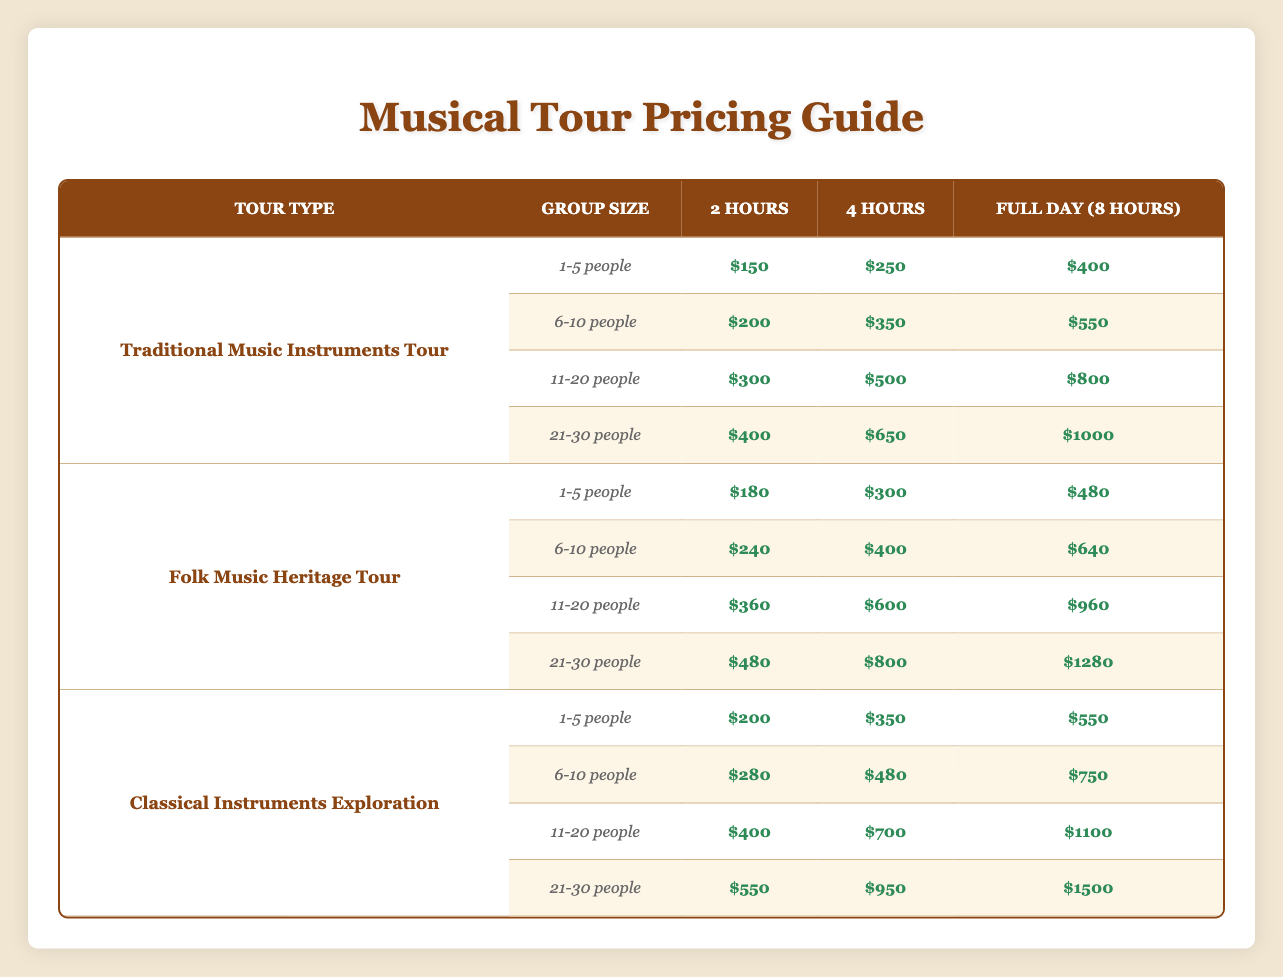What is the cost of a 4-hour Traditional Music Instruments Tour for a group of 6-10 people? Referring to the pricing table under Traditional Music Instruments Tour, for a group size of 6-10 people, the price for a 4-hour tour is $350.
Answer: $350 How much does it cost for a group of 1-5 people to take a Full day (8 hours) Folk Music Heritage Tour? Looking at the Folk Music Heritage Tour row, the price for a Full day (8 hours) tour for a group of 1-5 people is $480.
Answer: $480 Is the price for a 2-hour Classical Instruments Exploration Tour more expensive for 11-20 people than for 6-10 people? In the Classical Instruments Exploration section, the price for 2 hours for 11-20 people is $400 and for 6-10 people is $280. Since $400 is greater than $280, the answer is yes.
Answer: Yes What is the total cost for a Full day (8 hours) tour for a group of 21-30 people for both Folk Music Heritage and Classical Instruments Exploration? First, find the costs for a Full day (8 hours) for both tours: Folk Music Heritage Tour for 21-30 people is $1280, and Classical Instruments Exploration for 21-30 people is $1500. Summing these gives $1280 + $1500 = $2780.
Answer: $2780 What is the average price of a 2-hour tour across all group sizes for the Classical Instruments Exploration? The 2-hour prices for Classical Instruments Exploration are $200 (1-5), $280 (6-10), $400 (11-20), and $550 (21-30). Adding these gives $200 + $280 + $400 + $550 = $1430. There are 4 group sizes, so the average is $1430 divided by 4, which equals $357.50.
Answer: $357.50 Is the cost for a 4-hour Folk Music Heritage Tour for 11-20 people less than the cost of a 2-hour Traditional Music Instruments Tour for the same group? Checking the Folk Music Heritage Tour for 11-20 people shows a 4-hour price of $600, while for Traditional Music Instruments Tour, the 2-hour price for the same group is $300. Since $600 is greater than $300, the answer is no.
Answer: No What is the difference in price between a Full day (8 hours) tour for 1-5 people in Classical Instruments Exploration and the same for 21-30 people? From the table, the Full day price for 1-5 people in Classical Instruments Exploration is $550, and for 21-30 people, it is $1500. The difference is $1500 - $550 = $950.
Answer: $950 What is the highest price for any group size in the Traditional Music Instruments Tour? Examining the Traditional Music Instruments Tour, the highest price is for the Full day (8 hours) for 21-30 people, which is $1000.
Answer: $1000 